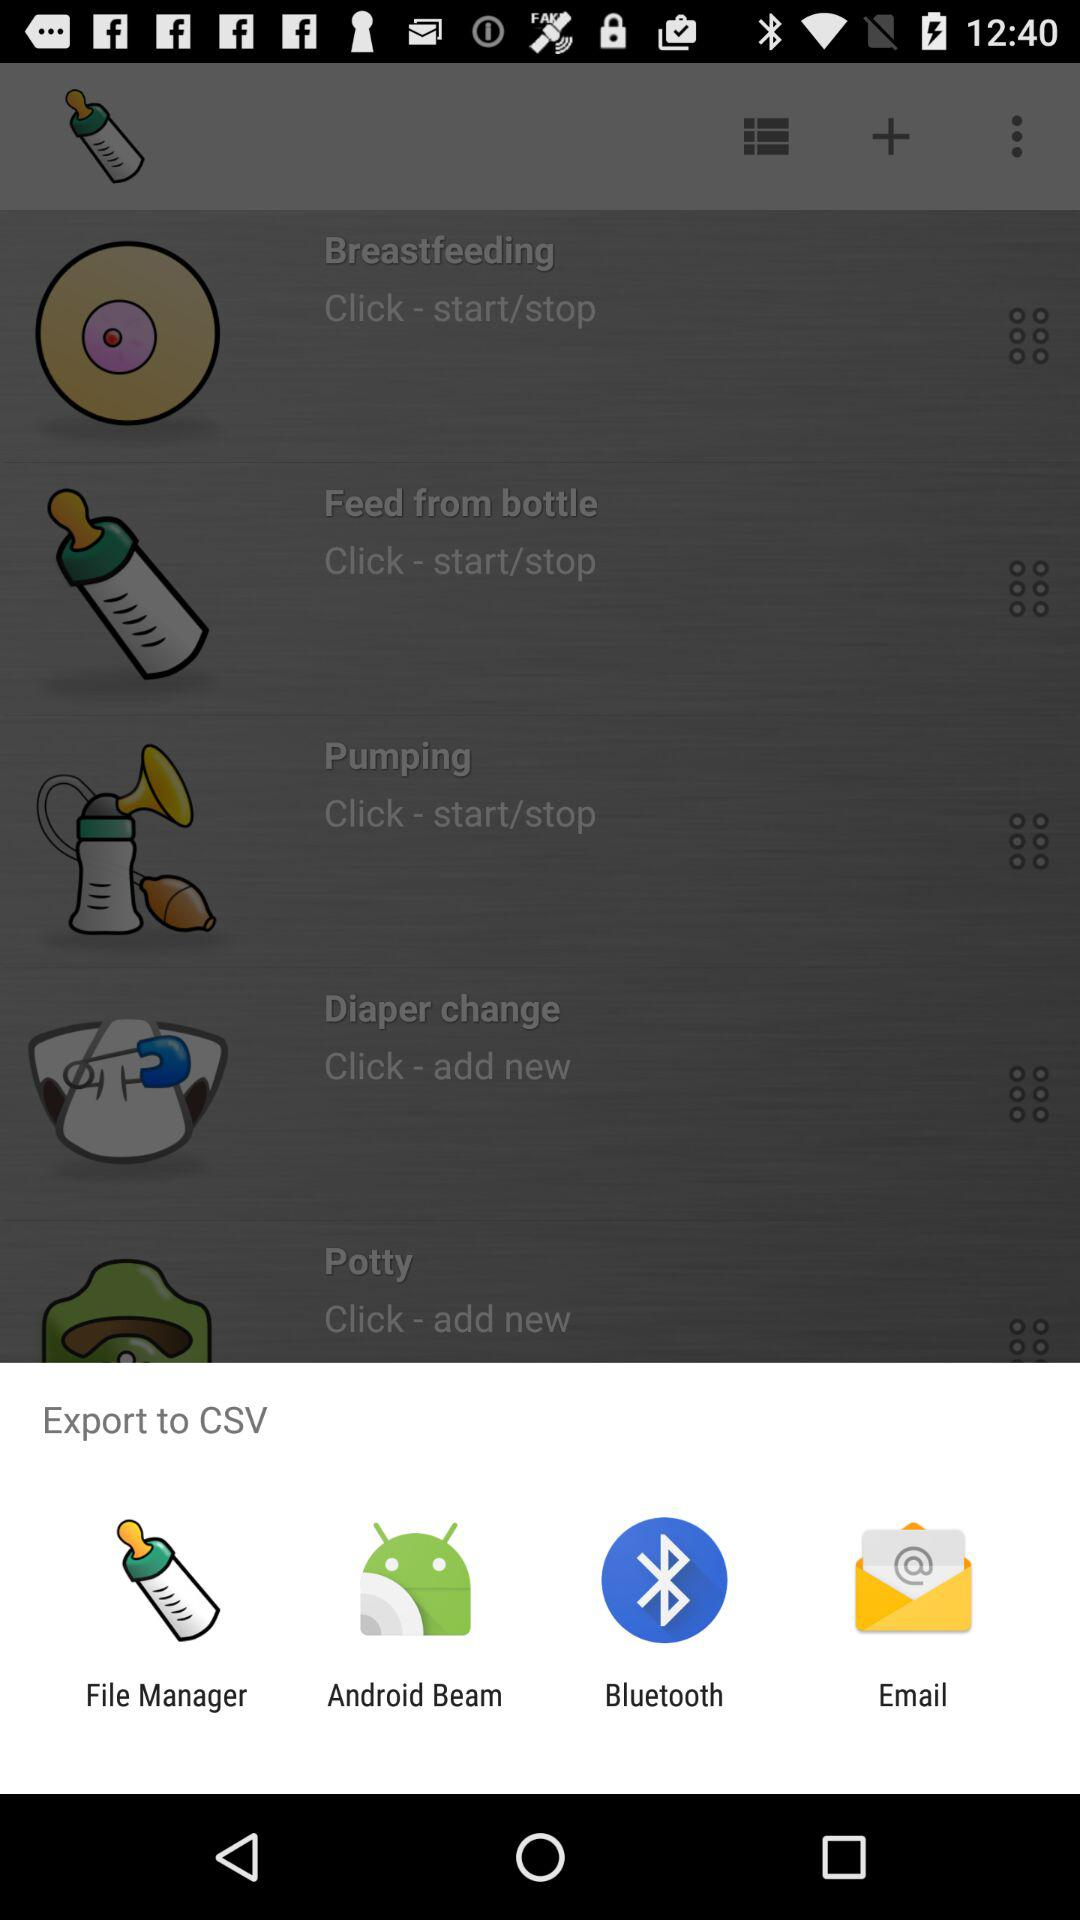Which application can be used to export to CSV? You can use "File Manager", "Android Beam", "Bluetooth" and "Email". 